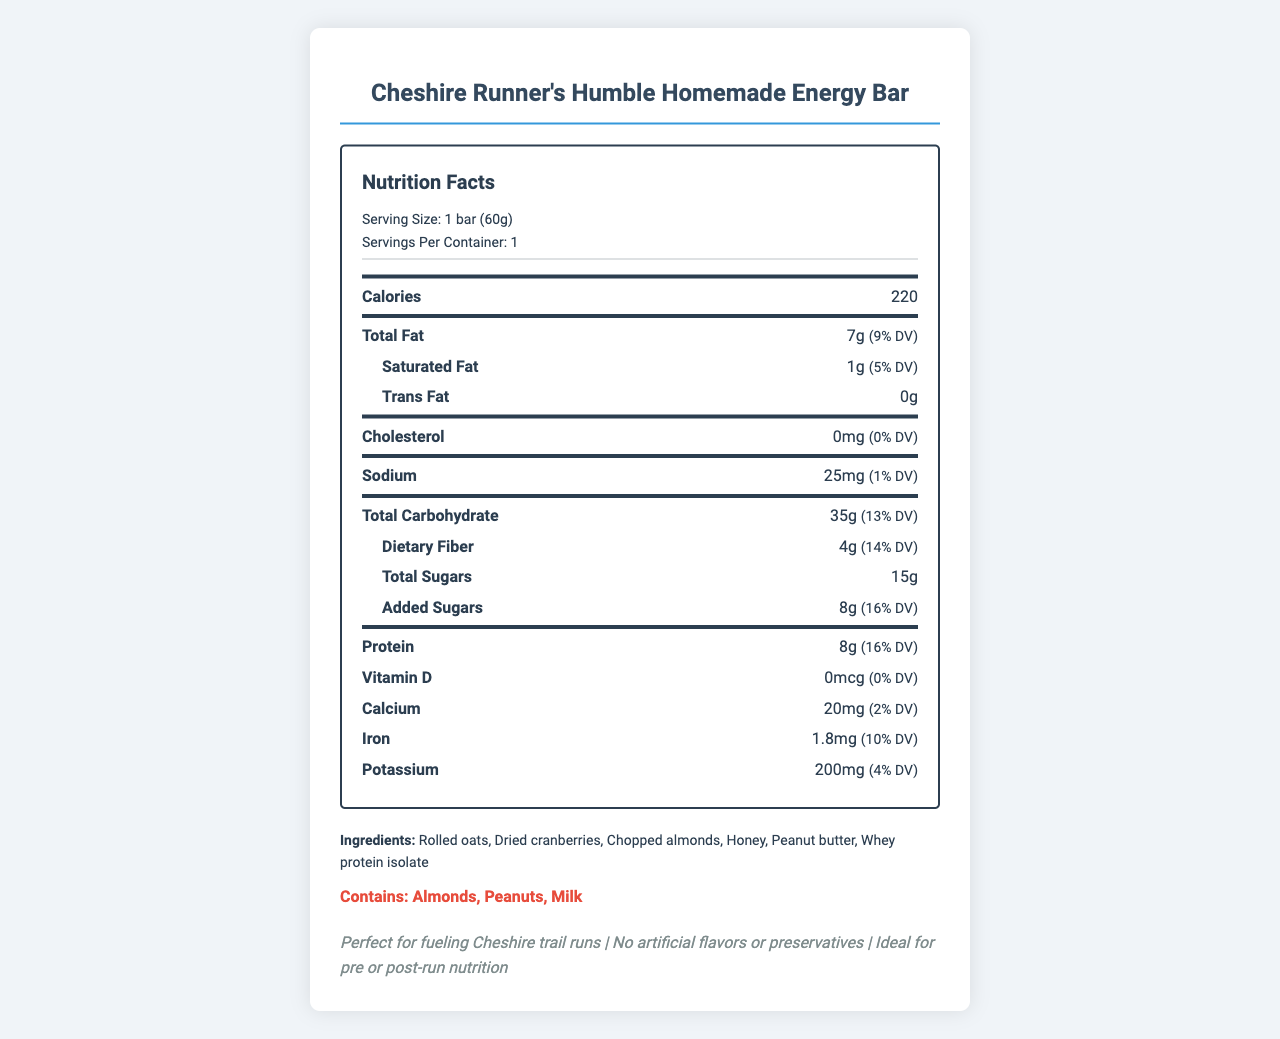what is the serving size for the energy bar? The serving size is listed under "Serving Size" as 1 bar (60g).
Answer: 1 bar (60g) how many grams of protein are in the energy bar? The protein content is listed as 8g in the nutrient section.
Answer: 8g how many total carbohydrates are in the energy bar? The total carbohydrate content is listed as 35g in the nutrient section.
Answer: 35g what percentage of the daily value (DV) for protein does the energy bar provide? Next to the protein amount, it states "(16% DV)" indicating the percentage of the daily value.
Answer: 16% how much dietary fiber does the energy bar contain? The dietary fiber content is listed as 4g in the nutrient section.
Answer: 4g which of the following ingredients are allergens listed on the label? A. Wheat, B. Peanuts, C. Soy The allergen section lists "Contains: Almonds, Peanuts, Milk."
Answer: B does the energy bar contain artificial flavors or preservatives? (Yes/No) The label specifically mentions "No artificial flavors or preservatives" in the additional info section.
Answer: No describe the nutritional composition of the energy bar This summary includes all main nutrient values and their relevant daily values based on the document's information.
Answer: The energy bar contains 220 calories per serving, which is 1 bar (60g). It has 7g of total fat (9% DV), 35g of total carbohydrates (13% DV) including 4g of dietary fiber (14% DV) and 15g of sugars (8g added sugars contributing to 16% DV), and 8g of protein (16% DV). It also includes small amounts of calcium, iron, and potassium. how many servings are in the container? The servings per container are indicated as 1 under the serving information.
Answer: 1 how much added sugar does the energy bar have? The content of added sugars is listed as 8g in the nutrient section.
Answer: 8g what is the main ingredient in the Cheshire Runner's Humble Homemade Energy Bar? A. Honey, B. Peanut Butter, C. Rolled Oats, D. Whey Protein Isolate The main ingredients are rolled oats, dried cranberries, chopped almonds, honey, peanut butter, and whey protein isolate. Rolled oats are listed first indicating they are the main ingredient.
Answer: C what is the amount of potassium in the energy bar? The potassium content is listed as 200mg in the nutrient section.
Answer: 200mg how many calories does the energy bar contain? The calorie content is listed directly in the nutrient section as 220.
Answer: 220 what percentage of the daily value for total carbohydrates does the energy bar provide? The total carbohydrate section shows that it provides 13% of the daily value (DV).
Answer: 13% what is the amount of total sugars in the energy bar? The total sugars content is listed as 15g in the nutrient section.
Answer: 15g what is the expiration date of the energy bar? The document does not include any information about the expiration date.
Answer: Not enough information what is the amount of iron in the energy bar? A. 1mg, B. 1.5mg, C. 1.8mg, D. 2mg The iron content is listed as 1.8mg in the nutrient section.
Answer: C 